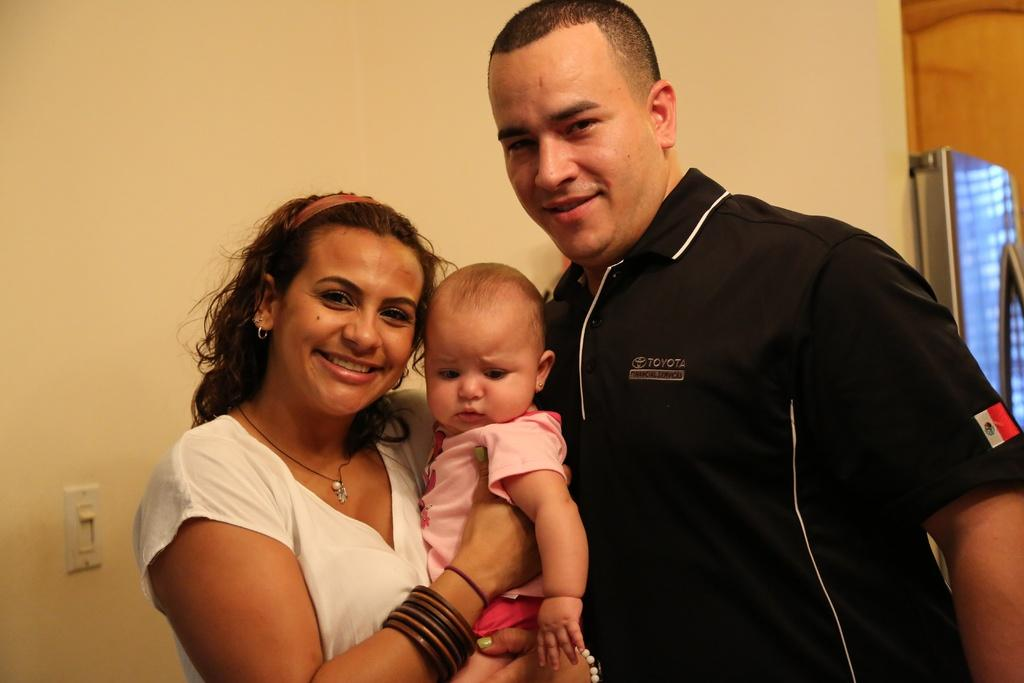Provide a one-sentence caption for the provided image. A Toyota employee poses with a woman and child. 